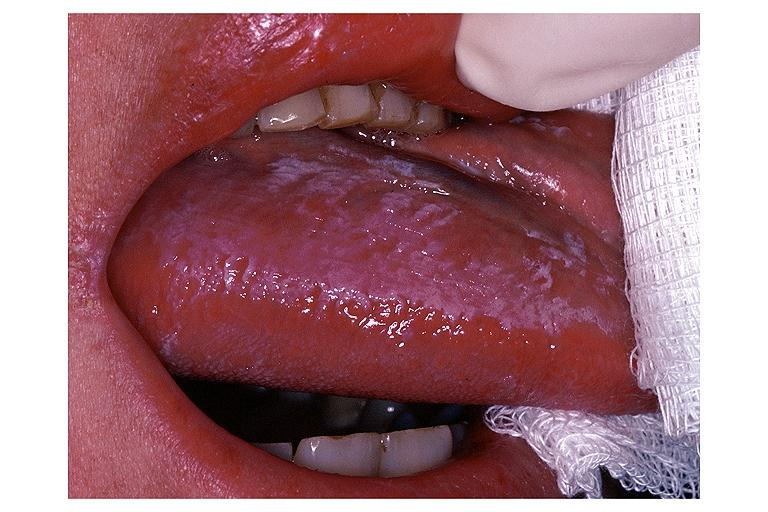where is this?
Answer the question using a single word or phrase. Oral 